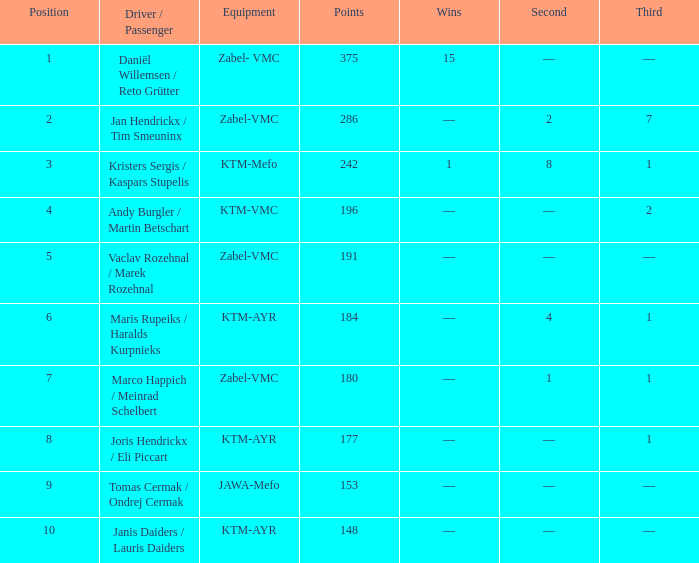Who was the pilot/occupant when the spot was below 8, the third was 1, and there was 1 success? Kristers Sergis / Kaspars Stupelis. 